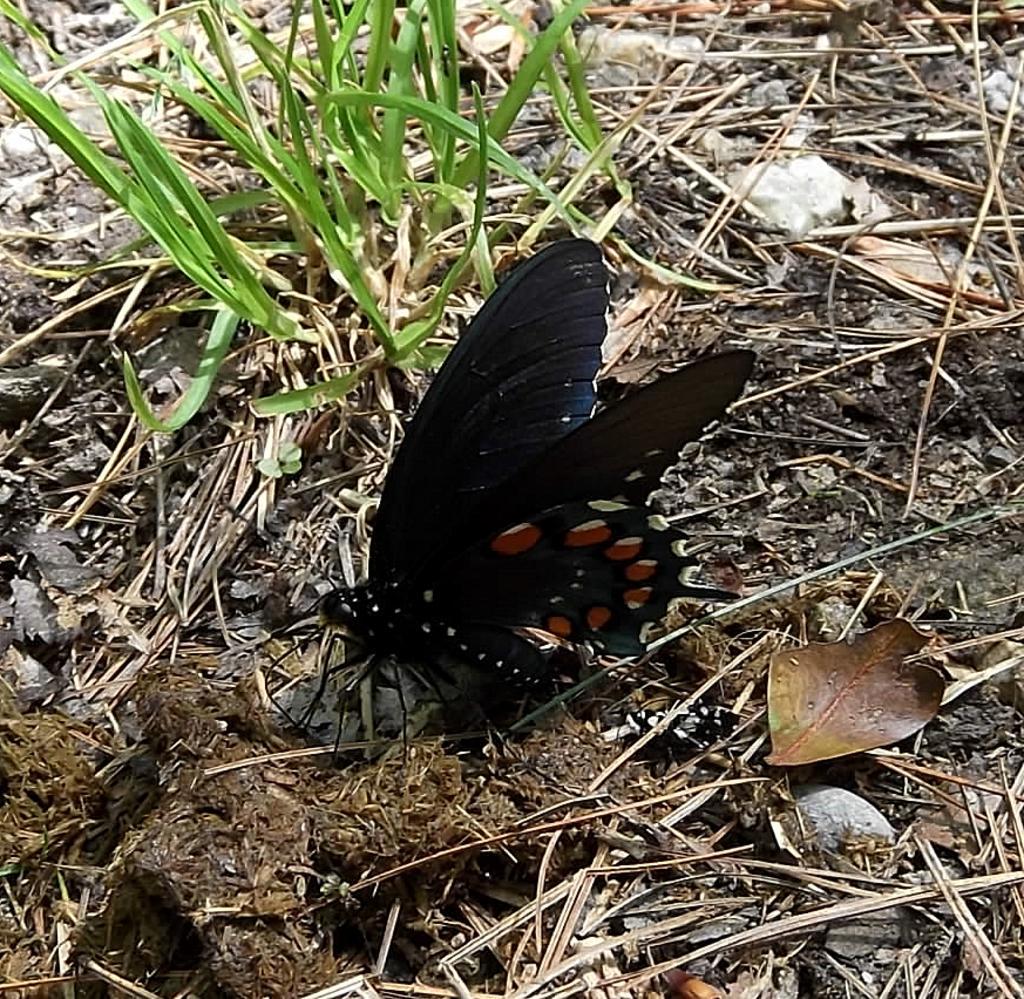Please provide a concise description of this image. In the center of the image there is a butterfly. At the bottom of the image there is dried grass. 